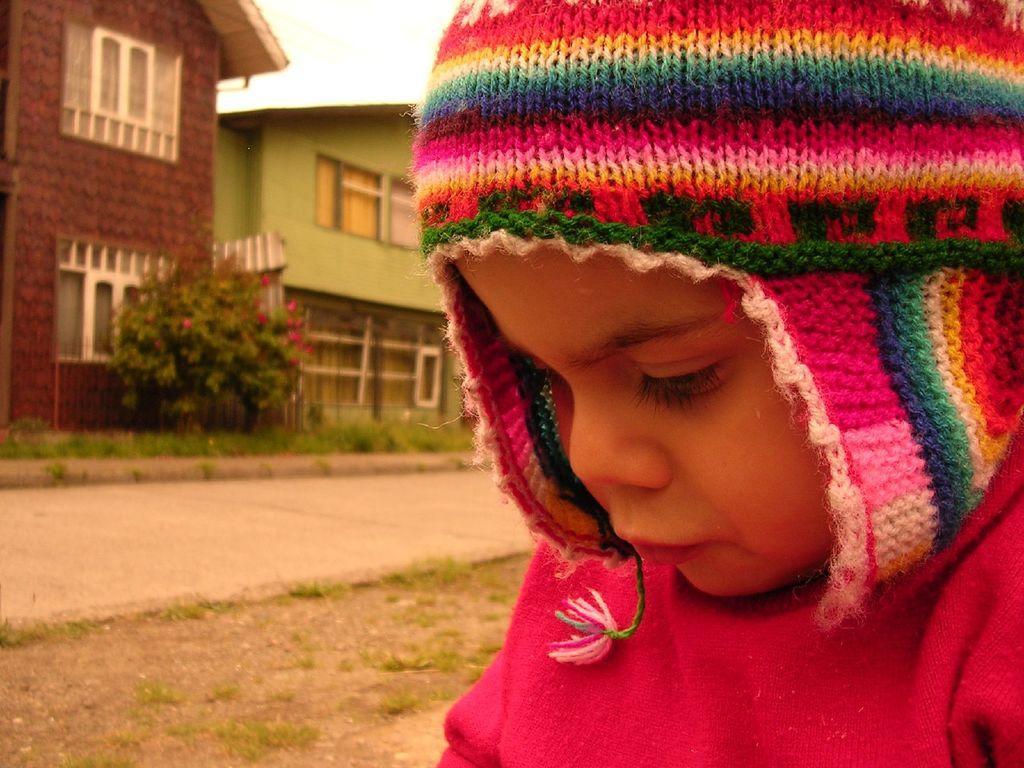How would you summarize this image in a sentence or two? In this image there is a kid with a monkey cap , and in the background there is grass, plant with flowers, houses, sky. 